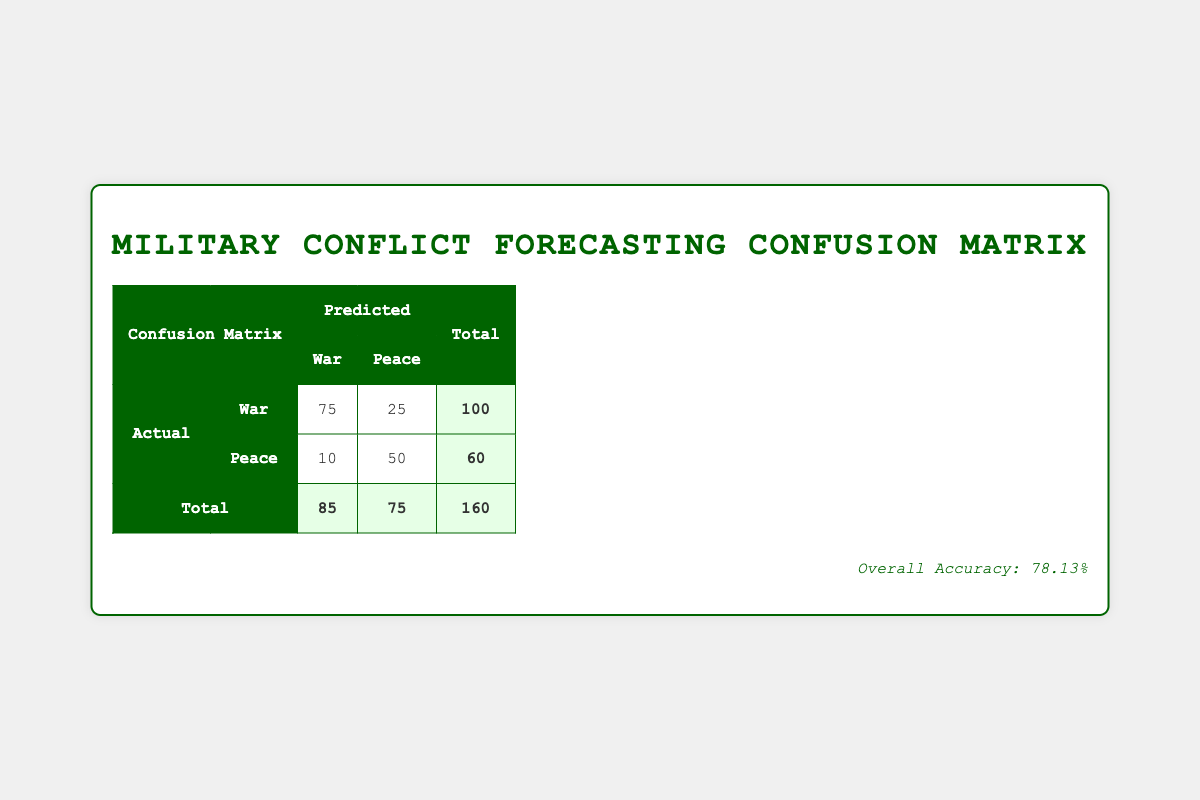What is the total number of predictions for Peace? In the table, the predicted values for Peace are shown in the last row under the "Peace" column. The values are 25 (False Peace) and 50 (True Peace). To get the total, you add these two numbers: 25 + 50 = 75.
Answer: 75 What is the total number of actual conflicts identified as War? From the table, the actual number of conflicts identified as War is 100. This is noted in the row labeled "War" under the "Total" column.
Answer: 100 How many instances were falsely predicted as War? The number of instances falsely predicted as War is shown in the row for "Peace" under the "War" predicted column, which has a value of 10.
Answer: 10 What is the Overall Accuracy of the predictive model? The Overall Accuracy is presented at the bottom of the table, calculated as the number of correct predictions divided by the total number of predictions. Here, it shows 78.13%.
Answer: 78.13% How many actual peacetime situations were correctly classified? The number of actual peacetime situations correctly classified is found in the "True Peace" value under the "Predicted Peace" column, which shows 50.
Answer: 50 If there were a total of 160 predictions, what percentage was War? The total number of predictions is 160. The predictions for War are 85 (True War + False War). To find the percentage, use the formula: (85/160) * 100, which calculates to approximately 53.125%.
Answer: 53.125% Is the model more accurate in predicting War or Peace? The model's accuracy can be gauged by looking at the number of True War (75) versus True Peace (50). Here, True War is higher, indicating that the model is more accurate in predicting War than Peace.
Answer: Yes What is the difference between the number of True Wars and True Peaces predicted? The number of True Wars predicted is 75 and the number of True Peaces predicted is 50. The difference is calculated as 75 - 50 = 25.
Answer: 25 What fraction of the total predictions were correctly classified? The number of correctly classified predictions includes True War (75) and True Peace (50), totaling 75 + 50 = 125 correct predictions. The total predictions are 160. Thus, the fraction is 125/160.
Answer: 125/160 or 0.7813 